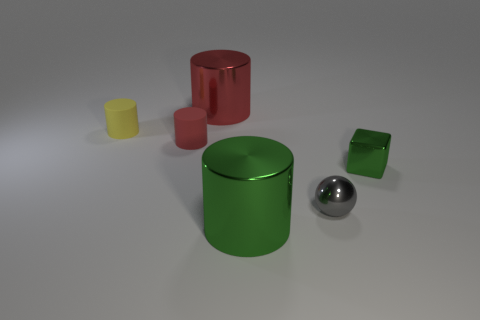There is a green thing that is to the left of the gray metallic object; does it have the same shape as the red metal object that is left of the big green object?
Keep it short and to the point. Yes. What number of matte things are either tiny cylinders or cylinders?
Make the answer very short. 2. What material is the large cylinder that is the same color as the small shiny cube?
Your answer should be very brief. Metal. Is there anything else that is the same shape as the tiny red object?
Provide a succinct answer. Yes. There is a big object that is behind the large green metal cylinder; what is its material?
Provide a succinct answer. Metal. Does the large thing in front of the large red thing have the same material as the big red object?
Make the answer very short. Yes. What number of objects are either metal objects or green metal things on the right side of the gray ball?
Provide a succinct answer. 4. There is a red matte thing that is the same shape as the tiny yellow thing; what is its size?
Offer a very short reply. Small. Is there anything else that has the same size as the ball?
Make the answer very short. Yes. Are there any big green shiny things on the left side of the large green shiny cylinder?
Provide a succinct answer. No. 